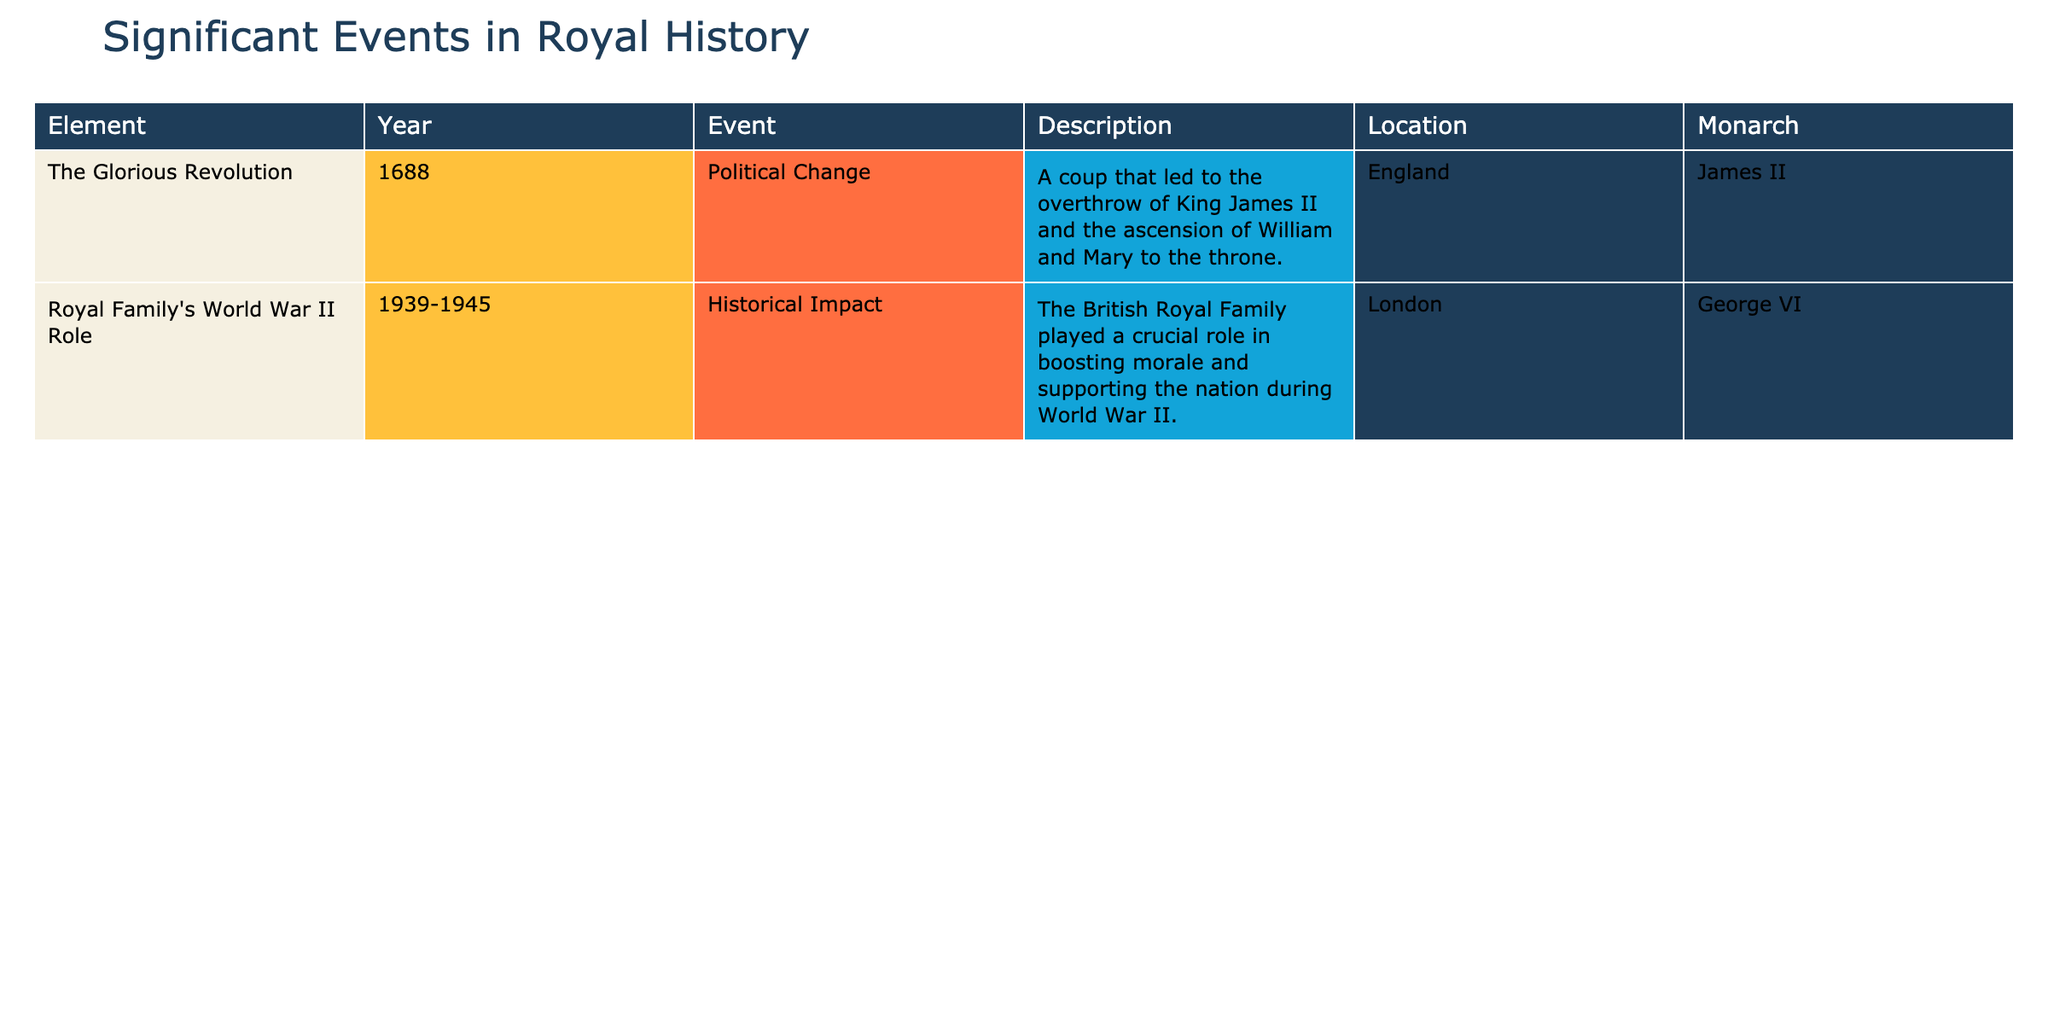What significant political change occurred in 1688? The event marked as "The Glorious Revolution" in 1688 represents a coup that resulted in the overthrow of King James II and the ascension of William and Mary to the throne. This event is clearly stated in the table.
Answer: The Glorious Revolution Which monarch was involved in the World War II role between 1939 and 1945? The table indicates that during the years 1939 to 1945, the monarch involved was George VI, as explicitly listed in the monarch column for the World War II role event.
Answer: George VI Were William and Mary directly involved in any event listed in the table? The table does not mention William and Mary in any other event except for "The Glorious Revolution." Therefore, there are no other occurrences associated with them listed in the table.
Answer: No What year did the British Royal Family support the nation during World War II? The table specifies the years 1939 to 1945 for the event regarding the British Royal Family's role during World War II which is clearly highlighted in the year column of that event.
Answer: 1939-1945 Which event took place in England? Both events listed in the table take place in England as inferred from the location column. Therefore, the answer encompasses both events, as they both took place in the same country.
Answer: The Glorious Revolution and Royal Family's World War II Role How many significant events listed occurred before the 20th century? "The Glorious Revolution" is the only event listed that occurred before the 20th century, specifically in 1688. The other event occurred between 1939-1945, which is in the 20th century.
Answer: 1 What was the primary role of the British Royal Family during World War II? The description in the table indicates that the British Royal Family played a crucial role in boosting morale and supporting the nation during the war, concisely summarizing their involvement as morale support for the nation.
Answer: Boosting morale and supporting the nation Which monarch's reign was considered a time of significant political change in the 17th century? The table indicates that King James II was the monarch during "The Glorious Revolution" in 1688, which represents a significant political change, indicating his reign was marked by this upheaval.
Answer: King James II 